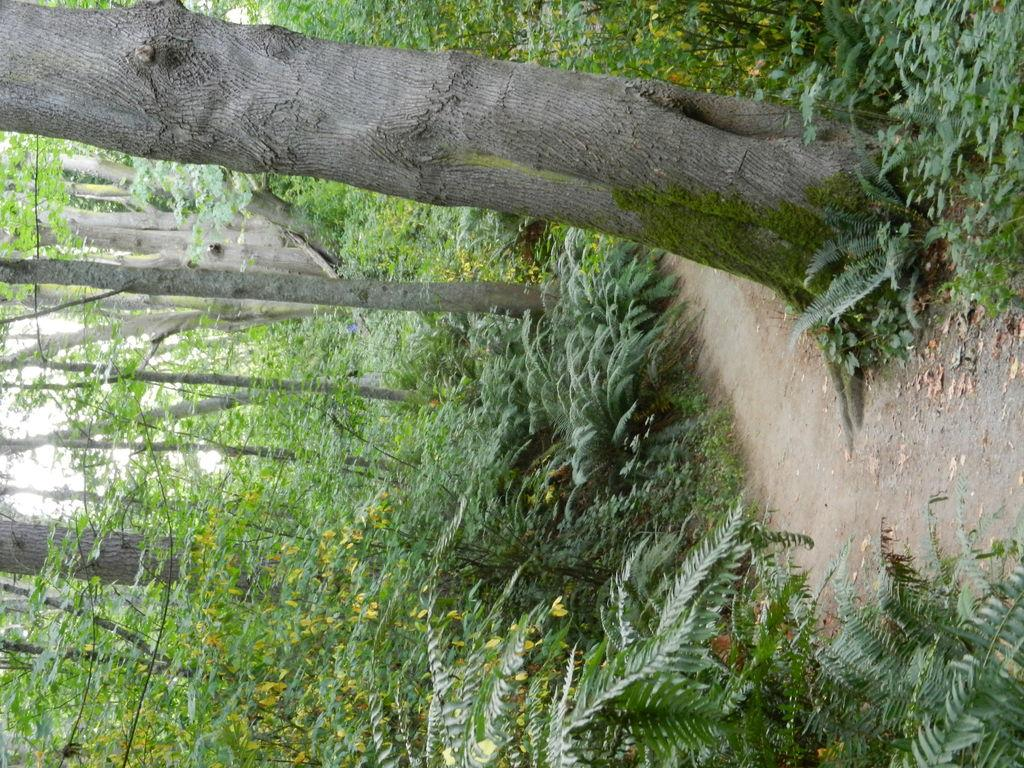What type of natural environment is depicted in the image? There is a surface with plants and trees in the image. Can you describe the ground near the plants and trees? There is a part of a muddy surface near the plants and trees. What can be seen in the background of the image? The sky is visible through the trees in the image. How many women are using the kettle in the image? There are no women or kettle present in the image. 